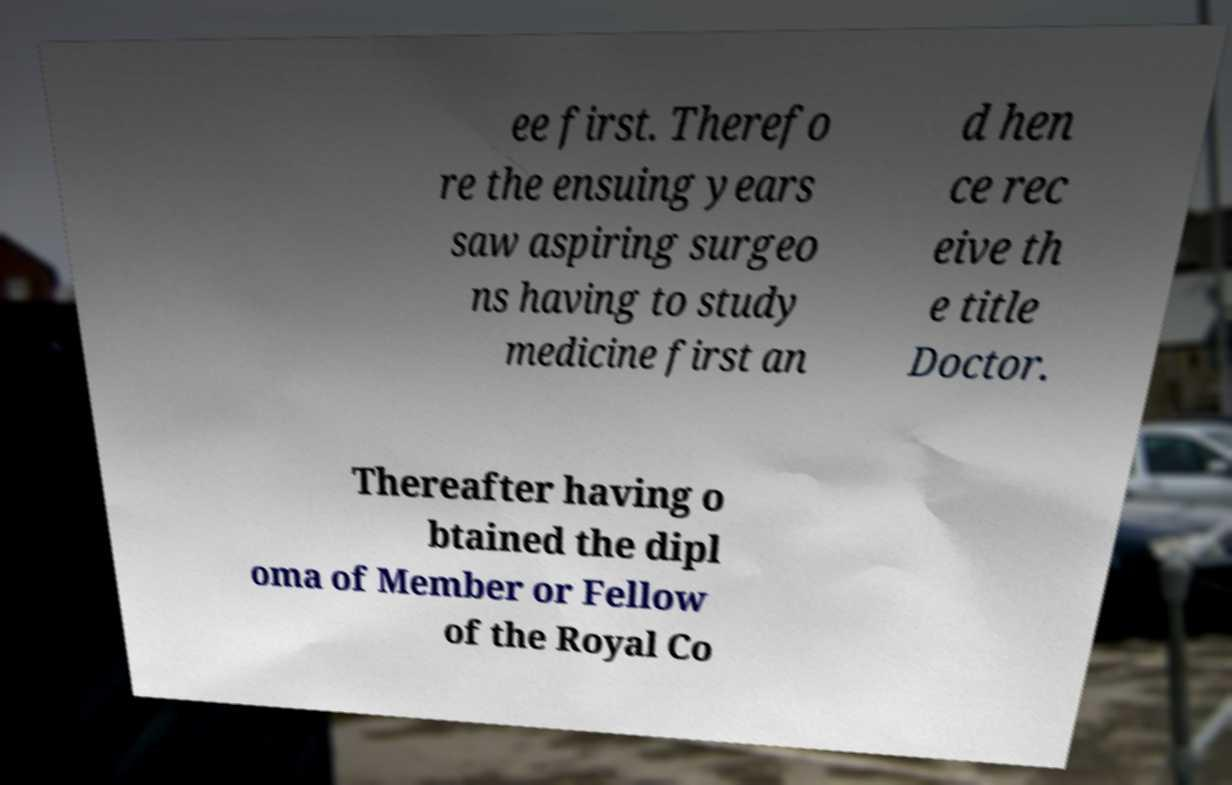Please identify and transcribe the text found in this image. ee first. Therefo re the ensuing years saw aspiring surgeo ns having to study medicine first an d hen ce rec eive th e title Doctor. Thereafter having o btained the dipl oma of Member or Fellow of the Royal Co 